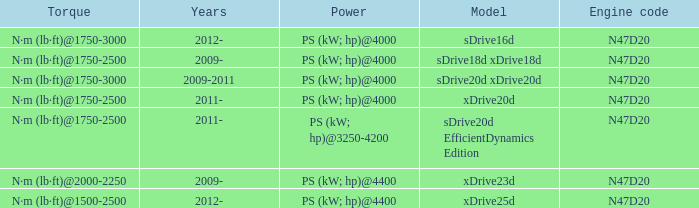What years did the sdrive16d model have a Torque of n·m (lb·ft)@1750-3000? 2012-. 